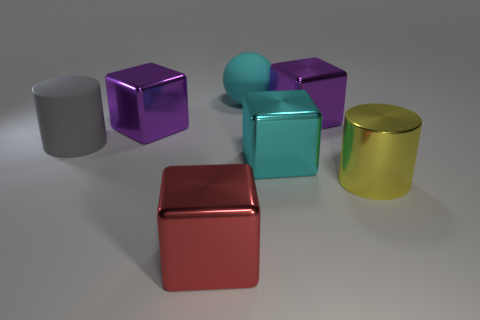How many objects are purple shiny cubes or large yellow shiny things? In the image, there are three objects that match the description: two purple shiny cubes and one large yellow shiny cylinder. These are distinct in their color and shine, indicating their standout features among the other objects. 